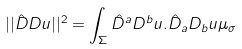<formula> <loc_0><loc_0><loc_500><loc_500>| | \hat { D } D u | | ^ { 2 } = \int _ { \Sigma } \hat { D } ^ { a } D ^ { b } u . \hat { D } _ { a } D _ { b } u \mu _ { \sigma }</formula> 